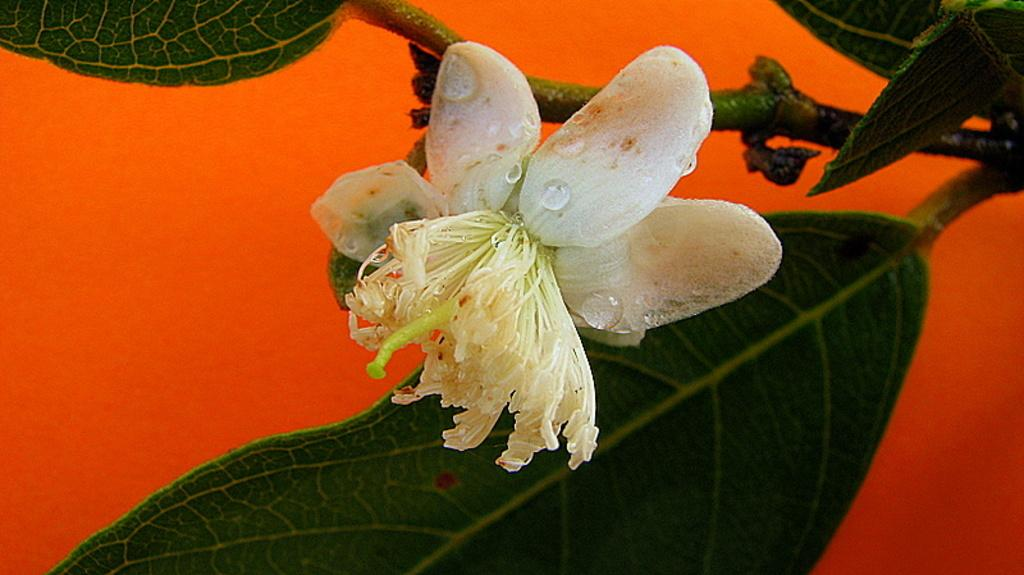What type of plant parts can be seen in the image? The image contains leaves, stems, and a flower. Are there any visible signs of moisture on the flower? Yes, there are water droplets on the flower. What color is the background of the image? The background of the image is red. What type of cork can be seen in the image? There is no cork present in the image. Is there a letter addressed to the creator of the image? There is no letter or creator mentioned in the image. 